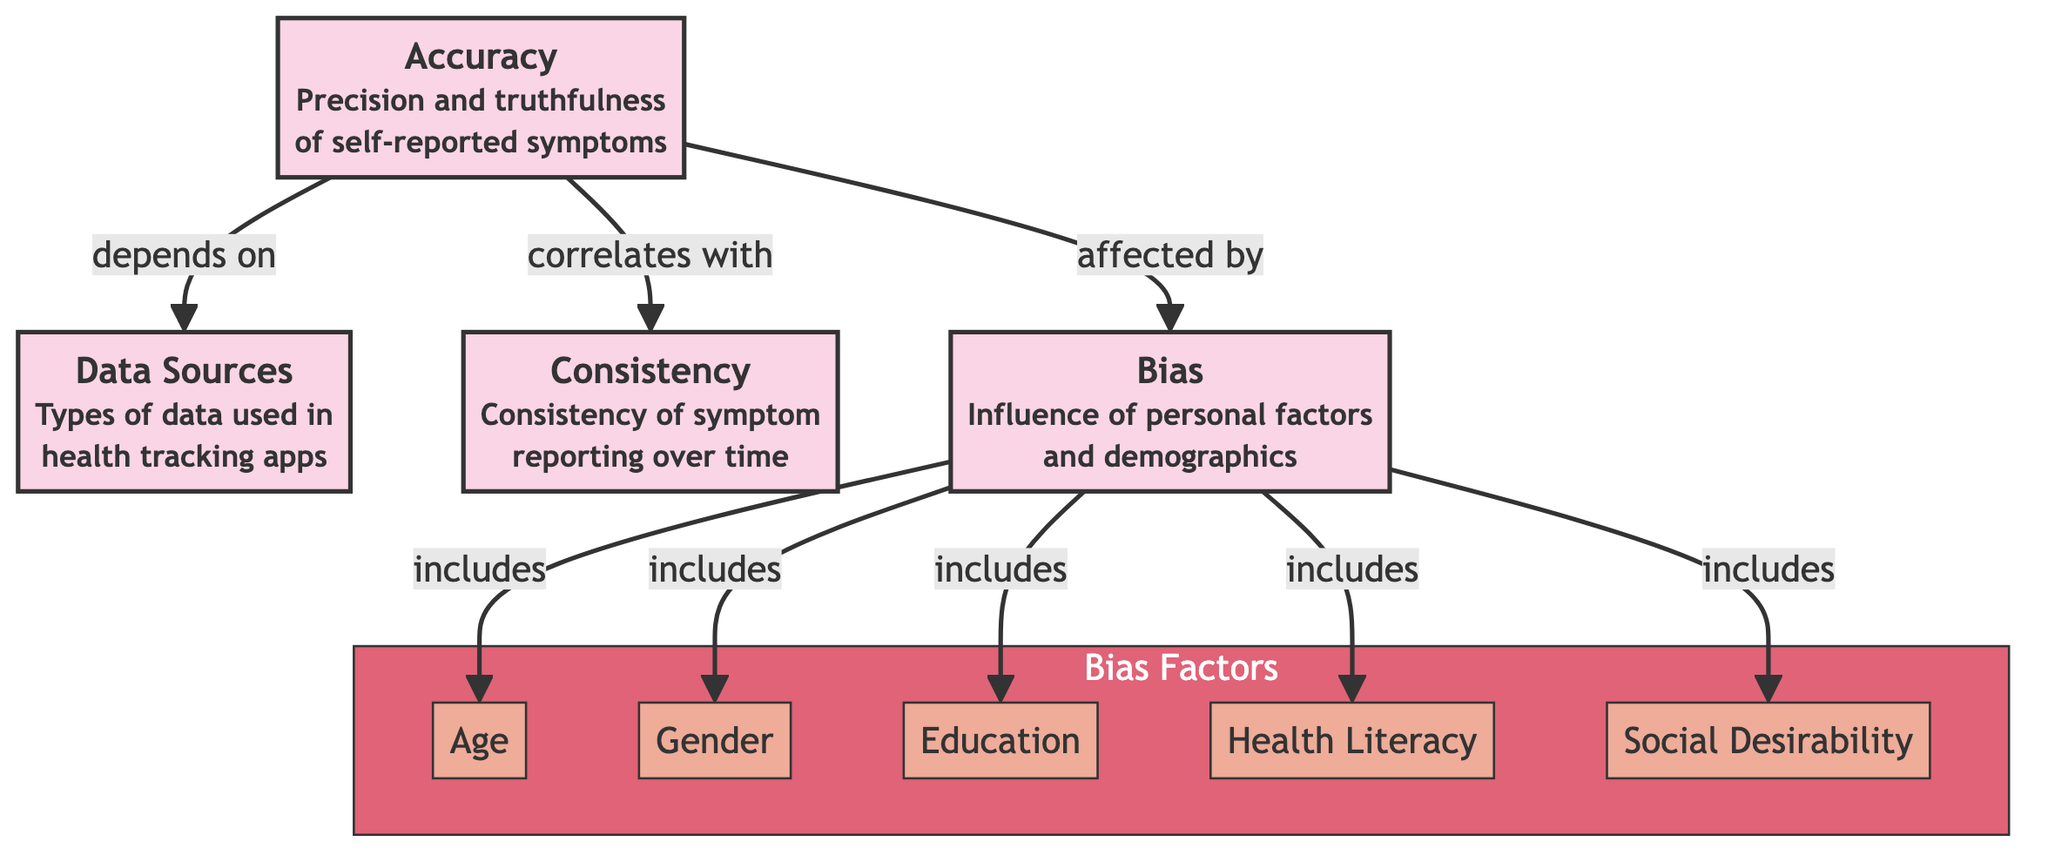What are the four main nodes in this diagram? The diagram lists four main nodes: Accuracy, Data Sources, Consistency, and Bias. These are visibly separated from the sub-nodes and emphasized in the flowchart.
Answer: Accuracy, Data Sources, Consistency, Bias How many bias factors are listed in the subgraph? There are five bias factors identified in the subgraph: Age, Gender, Education, Health Literacy, and Social Desirability. This count is derived from the subgraph labeled "Bias Factors."
Answer: Five What does "Accuracy" depend on according to the diagram? The diagram shows that "Accuracy" depends on "Data Sources." This relationship is indicated by an arrow connecting the two nodes.
Answer: Data Sources Which factor is associated with bias along with social desirability? The diagram indicates that both Age and Social Desirability are included as factors that influence bias. This is stated in the relationship shown under the "Bias" main node.
Answer: Age How many edges flow from the "Bias" node to the factors listed in the subgraph? There are five edges that flow from the "Bias" node, corresponding to each of the individual factors (Age, Gender, Education, Health Literacy, Social Desirability) included in the Bias subgraph.
Answer: Five What concept is shown to correlate with accuracy? According to the diagram, "Consistency" correlates with "Accuracy." This correlation is explicitly indicated by an arrow pointing from "Consistency" to "Accuracy."
Answer: Consistency How many total nodes are there in this diagram? The diagram has a total of nine nodes: four main nodes (Accuracy, Data Sources, Consistency, Bias) and five sub-nodes (Age, Gender, Education, Health Literacy, Social Desirability). Therefore, the total count is nine.
Answer: Nine What relationship is depicted between accuracy and bias? The diagram describes that "Accuracy" is affected by "Bias," illustrating this with a directional arrow from "Bias" to "Accuracy."
Answer: Affected by Which demographic factor is not explicitly listed as a bias factor? The diagram does not explicitly include factors like income or ethnicity as bias factors, as it only lists Age, Gender, Education, Health Literacy, and Social Desirability under bias.
Answer: Income or Ethnicity 